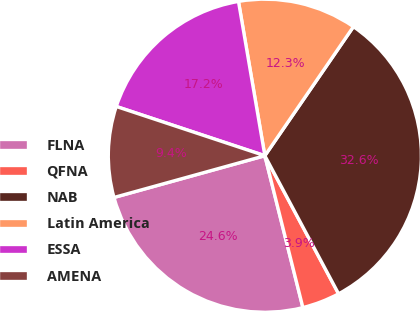Convert chart. <chart><loc_0><loc_0><loc_500><loc_500><pie_chart><fcel>FLNA<fcel>QFNA<fcel>NAB<fcel>Latin America<fcel>ESSA<fcel>AMENA<nl><fcel>24.61%<fcel>3.9%<fcel>32.62%<fcel>12.27%<fcel>17.21%<fcel>9.39%<nl></chart> 